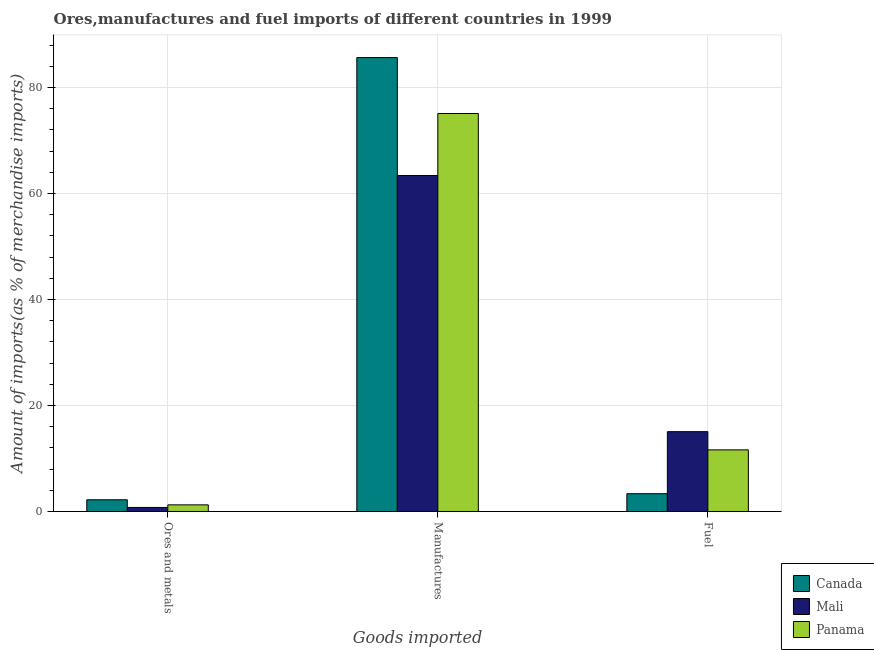Are the number of bars per tick equal to the number of legend labels?
Ensure brevity in your answer.  Yes. Are the number of bars on each tick of the X-axis equal?
Give a very brief answer. Yes. What is the label of the 1st group of bars from the left?
Provide a succinct answer. Ores and metals. What is the percentage of fuel imports in Mali?
Offer a terse response. 15.06. Across all countries, what is the maximum percentage of ores and metals imports?
Provide a short and direct response. 2.21. Across all countries, what is the minimum percentage of fuel imports?
Ensure brevity in your answer.  3.36. In which country was the percentage of manufactures imports maximum?
Your answer should be very brief. Canada. In which country was the percentage of manufactures imports minimum?
Make the answer very short. Mali. What is the total percentage of manufactures imports in the graph?
Offer a very short reply. 224.19. What is the difference between the percentage of fuel imports in Mali and that in Canada?
Provide a succinct answer. 11.71. What is the difference between the percentage of ores and metals imports in Panama and the percentage of fuel imports in Canada?
Provide a succinct answer. -2.11. What is the average percentage of manufactures imports per country?
Provide a succinct answer. 74.73. What is the difference between the percentage of manufactures imports and percentage of fuel imports in Canada?
Your response must be concise. 82.31. In how many countries, is the percentage of ores and metals imports greater than 48 %?
Offer a very short reply. 0. What is the ratio of the percentage of manufactures imports in Canada to that in Panama?
Your response must be concise. 1.14. Is the difference between the percentage of fuel imports in Panama and Canada greater than the difference between the percentage of ores and metals imports in Panama and Canada?
Offer a terse response. Yes. What is the difference between the highest and the second highest percentage of ores and metals imports?
Your response must be concise. 0.96. What is the difference between the highest and the lowest percentage of ores and metals imports?
Your response must be concise. 1.45. What does the 1st bar from the left in Manufactures represents?
Your response must be concise. Canada. What does the 3rd bar from the right in Ores and metals represents?
Give a very brief answer. Canada. How many bars are there?
Keep it short and to the point. 9. How many countries are there in the graph?
Provide a succinct answer. 3. What is the difference between two consecutive major ticks on the Y-axis?
Provide a succinct answer. 20. Are the values on the major ticks of Y-axis written in scientific E-notation?
Offer a terse response. No. Does the graph contain any zero values?
Make the answer very short. No. Does the graph contain grids?
Make the answer very short. Yes. Where does the legend appear in the graph?
Offer a very short reply. Bottom right. How are the legend labels stacked?
Offer a very short reply. Vertical. What is the title of the graph?
Make the answer very short. Ores,manufactures and fuel imports of different countries in 1999. Does "Nicaragua" appear as one of the legend labels in the graph?
Make the answer very short. No. What is the label or title of the X-axis?
Offer a terse response. Goods imported. What is the label or title of the Y-axis?
Make the answer very short. Amount of imports(as % of merchandise imports). What is the Amount of imports(as % of merchandise imports) of Canada in Ores and metals?
Ensure brevity in your answer.  2.21. What is the Amount of imports(as % of merchandise imports) of Mali in Ores and metals?
Keep it short and to the point. 0.76. What is the Amount of imports(as % of merchandise imports) of Panama in Ores and metals?
Your answer should be compact. 1.25. What is the Amount of imports(as % of merchandise imports) in Canada in Manufactures?
Your response must be concise. 85.67. What is the Amount of imports(as % of merchandise imports) in Mali in Manufactures?
Make the answer very short. 63.41. What is the Amount of imports(as % of merchandise imports) of Panama in Manufactures?
Offer a very short reply. 75.11. What is the Amount of imports(as % of merchandise imports) in Canada in Fuel?
Your answer should be very brief. 3.36. What is the Amount of imports(as % of merchandise imports) of Mali in Fuel?
Your answer should be very brief. 15.06. What is the Amount of imports(as % of merchandise imports) in Panama in Fuel?
Your answer should be very brief. 11.63. Across all Goods imported, what is the maximum Amount of imports(as % of merchandise imports) in Canada?
Give a very brief answer. 85.67. Across all Goods imported, what is the maximum Amount of imports(as % of merchandise imports) of Mali?
Make the answer very short. 63.41. Across all Goods imported, what is the maximum Amount of imports(as % of merchandise imports) in Panama?
Give a very brief answer. 75.11. Across all Goods imported, what is the minimum Amount of imports(as % of merchandise imports) in Canada?
Offer a very short reply. 2.21. Across all Goods imported, what is the minimum Amount of imports(as % of merchandise imports) in Mali?
Provide a succinct answer. 0.76. Across all Goods imported, what is the minimum Amount of imports(as % of merchandise imports) of Panama?
Give a very brief answer. 1.25. What is the total Amount of imports(as % of merchandise imports) in Canada in the graph?
Your response must be concise. 91.23. What is the total Amount of imports(as % of merchandise imports) of Mali in the graph?
Offer a very short reply. 79.23. What is the total Amount of imports(as % of merchandise imports) of Panama in the graph?
Your answer should be very brief. 87.99. What is the difference between the Amount of imports(as % of merchandise imports) in Canada in Ores and metals and that in Manufactures?
Offer a very short reply. -83.46. What is the difference between the Amount of imports(as % of merchandise imports) in Mali in Ores and metals and that in Manufactures?
Keep it short and to the point. -62.65. What is the difference between the Amount of imports(as % of merchandise imports) of Panama in Ores and metals and that in Manufactures?
Give a very brief answer. -73.86. What is the difference between the Amount of imports(as % of merchandise imports) in Canada in Ores and metals and that in Fuel?
Make the answer very short. -1.15. What is the difference between the Amount of imports(as % of merchandise imports) in Mali in Ores and metals and that in Fuel?
Offer a terse response. -14.31. What is the difference between the Amount of imports(as % of merchandise imports) in Panama in Ores and metals and that in Fuel?
Make the answer very short. -10.38. What is the difference between the Amount of imports(as % of merchandise imports) in Canada in Manufactures and that in Fuel?
Offer a very short reply. 82.31. What is the difference between the Amount of imports(as % of merchandise imports) in Mali in Manufactures and that in Fuel?
Make the answer very short. 48.34. What is the difference between the Amount of imports(as % of merchandise imports) of Panama in Manufactures and that in Fuel?
Make the answer very short. 63.49. What is the difference between the Amount of imports(as % of merchandise imports) of Canada in Ores and metals and the Amount of imports(as % of merchandise imports) of Mali in Manufactures?
Provide a succinct answer. -61.2. What is the difference between the Amount of imports(as % of merchandise imports) in Canada in Ores and metals and the Amount of imports(as % of merchandise imports) in Panama in Manufactures?
Keep it short and to the point. -72.9. What is the difference between the Amount of imports(as % of merchandise imports) of Mali in Ores and metals and the Amount of imports(as % of merchandise imports) of Panama in Manufactures?
Your response must be concise. -74.35. What is the difference between the Amount of imports(as % of merchandise imports) of Canada in Ores and metals and the Amount of imports(as % of merchandise imports) of Mali in Fuel?
Give a very brief answer. -12.85. What is the difference between the Amount of imports(as % of merchandise imports) in Canada in Ores and metals and the Amount of imports(as % of merchandise imports) in Panama in Fuel?
Make the answer very short. -9.42. What is the difference between the Amount of imports(as % of merchandise imports) of Mali in Ores and metals and the Amount of imports(as % of merchandise imports) of Panama in Fuel?
Your response must be concise. -10.87. What is the difference between the Amount of imports(as % of merchandise imports) of Canada in Manufactures and the Amount of imports(as % of merchandise imports) of Mali in Fuel?
Offer a very short reply. 70.6. What is the difference between the Amount of imports(as % of merchandise imports) in Canada in Manufactures and the Amount of imports(as % of merchandise imports) in Panama in Fuel?
Offer a very short reply. 74.04. What is the difference between the Amount of imports(as % of merchandise imports) of Mali in Manufactures and the Amount of imports(as % of merchandise imports) of Panama in Fuel?
Give a very brief answer. 51.78. What is the average Amount of imports(as % of merchandise imports) of Canada per Goods imported?
Ensure brevity in your answer.  30.41. What is the average Amount of imports(as % of merchandise imports) of Mali per Goods imported?
Provide a succinct answer. 26.41. What is the average Amount of imports(as % of merchandise imports) in Panama per Goods imported?
Your answer should be compact. 29.33. What is the difference between the Amount of imports(as % of merchandise imports) of Canada and Amount of imports(as % of merchandise imports) of Mali in Ores and metals?
Ensure brevity in your answer.  1.45. What is the difference between the Amount of imports(as % of merchandise imports) of Canada and Amount of imports(as % of merchandise imports) of Panama in Ores and metals?
Provide a short and direct response. 0.96. What is the difference between the Amount of imports(as % of merchandise imports) in Mali and Amount of imports(as % of merchandise imports) in Panama in Ores and metals?
Offer a very short reply. -0.49. What is the difference between the Amount of imports(as % of merchandise imports) in Canada and Amount of imports(as % of merchandise imports) in Mali in Manufactures?
Keep it short and to the point. 22.26. What is the difference between the Amount of imports(as % of merchandise imports) in Canada and Amount of imports(as % of merchandise imports) in Panama in Manufactures?
Keep it short and to the point. 10.55. What is the difference between the Amount of imports(as % of merchandise imports) of Mali and Amount of imports(as % of merchandise imports) of Panama in Manufactures?
Your answer should be compact. -11.71. What is the difference between the Amount of imports(as % of merchandise imports) of Canada and Amount of imports(as % of merchandise imports) of Mali in Fuel?
Offer a very short reply. -11.71. What is the difference between the Amount of imports(as % of merchandise imports) of Canada and Amount of imports(as % of merchandise imports) of Panama in Fuel?
Make the answer very short. -8.27. What is the difference between the Amount of imports(as % of merchandise imports) of Mali and Amount of imports(as % of merchandise imports) of Panama in Fuel?
Offer a terse response. 3.44. What is the ratio of the Amount of imports(as % of merchandise imports) in Canada in Ores and metals to that in Manufactures?
Offer a terse response. 0.03. What is the ratio of the Amount of imports(as % of merchandise imports) in Mali in Ores and metals to that in Manufactures?
Give a very brief answer. 0.01. What is the ratio of the Amount of imports(as % of merchandise imports) in Panama in Ores and metals to that in Manufactures?
Your answer should be compact. 0.02. What is the ratio of the Amount of imports(as % of merchandise imports) in Canada in Ores and metals to that in Fuel?
Offer a very short reply. 0.66. What is the ratio of the Amount of imports(as % of merchandise imports) of Mali in Ores and metals to that in Fuel?
Make the answer very short. 0.05. What is the ratio of the Amount of imports(as % of merchandise imports) in Panama in Ores and metals to that in Fuel?
Offer a very short reply. 0.11. What is the ratio of the Amount of imports(as % of merchandise imports) in Canada in Manufactures to that in Fuel?
Make the answer very short. 25.52. What is the ratio of the Amount of imports(as % of merchandise imports) in Mali in Manufactures to that in Fuel?
Give a very brief answer. 4.21. What is the ratio of the Amount of imports(as % of merchandise imports) of Panama in Manufactures to that in Fuel?
Keep it short and to the point. 6.46. What is the difference between the highest and the second highest Amount of imports(as % of merchandise imports) of Canada?
Provide a short and direct response. 82.31. What is the difference between the highest and the second highest Amount of imports(as % of merchandise imports) of Mali?
Your answer should be compact. 48.34. What is the difference between the highest and the second highest Amount of imports(as % of merchandise imports) of Panama?
Offer a very short reply. 63.49. What is the difference between the highest and the lowest Amount of imports(as % of merchandise imports) of Canada?
Keep it short and to the point. 83.46. What is the difference between the highest and the lowest Amount of imports(as % of merchandise imports) in Mali?
Provide a short and direct response. 62.65. What is the difference between the highest and the lowest Amount of imports(as % of merchandise imports) of Panama?
Ensure brevity in your answer.  73.86. 